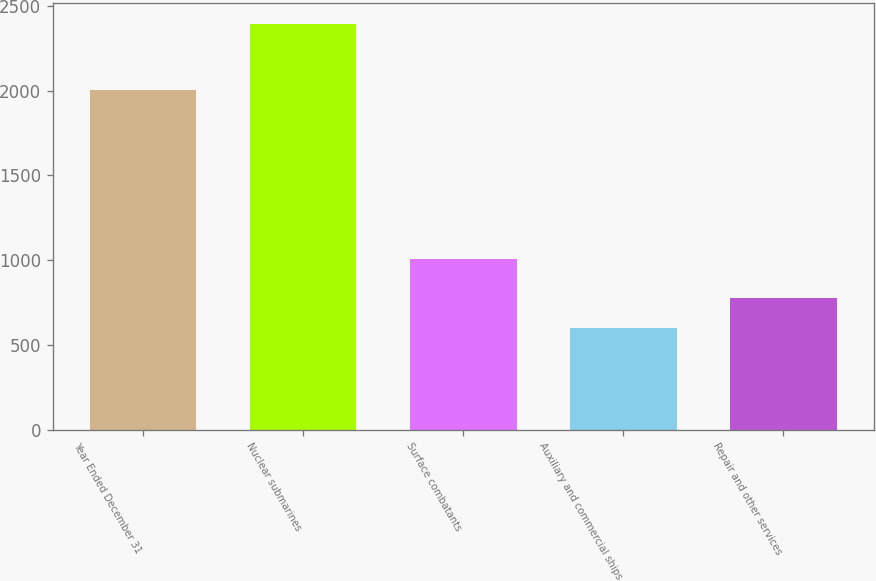Convert chart. <chart><loc_0><loc_0><loc_500><loc_500><bar_chart><fcel>Year Ended December 31<fcel>Nuclear submarines<fcel>Surface combatants<fcel>Auxiliary and commercial ships<fcel>Repair and other services<nl><fcel>2005<fcel>2396<fcel>1008<fcel>598<fcel>777.8<nl></chart> 